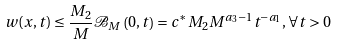<formula> <loc_0><loc_0><loc_500><loc_500>w ( x , t ) \leq \frac { M _ { 2 } } { M } \mathcal { B } _ { M } \left ( 0 , t \right ) = c ^ { \ast } M _ { 2 } M ^ { a _ { 3 } - 1 } t ^ { - a _ { 1 } } , \forall t > 0</formula> 